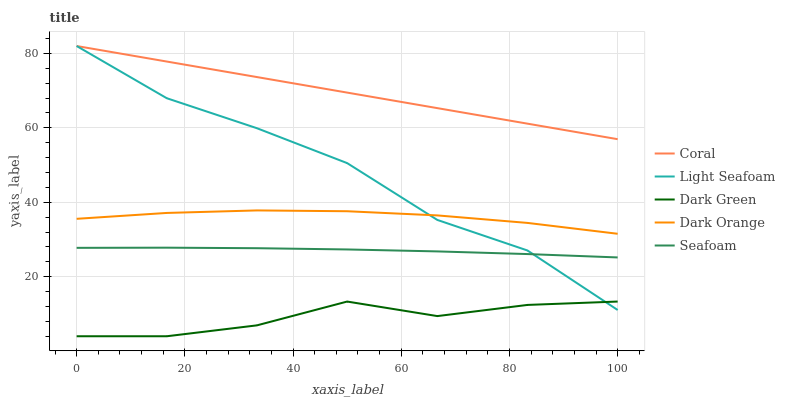Does Dark Green have the minimum area under the curve?
Answer yes or no. Yes. Does Coral have the maximum area under the curve?
Answer yes or no. Yes. Does Light Seafoam have the minimum area under the curve?
Answer yes or no. No. Does Light Seafoam have the maximum area under the curve?
Answer yes or no. No. Is Coral the smoothest?
Answer yes or no. Yes. Is Light Seafoam the roughest?
Answer yes or no. Yes. Is Light Seafoam the smoothest?
Answer yes or no. No. Is Coral the roughest?
Answer yes or no. No. Does Dark Green have the lowest value?
Answer yes or no. Yes. Does Light Seafoam have the lowest value?
Answer yes or no. No. Does Light Seafoam have the highest value?
Answer yes or no. Yes. Does Seafoam have the highest value?
Answer yes or no. No. Is Seafoam less than Dark Orange?
Answer yes or no. Yes. Is Coral greater than Seafoam?
Answer yes or no. Yes. Does Light Seafoam intersect Seafoam?
Answer yes or no. Yes. Is Light Seafoam less than Seafoam?
Answer yes or no. No. Is Light Seafoam greater than Seafoam?
Answer yes or no. No. Does Seafoam intersect Dark Orange?
Answer yes or no. No. 